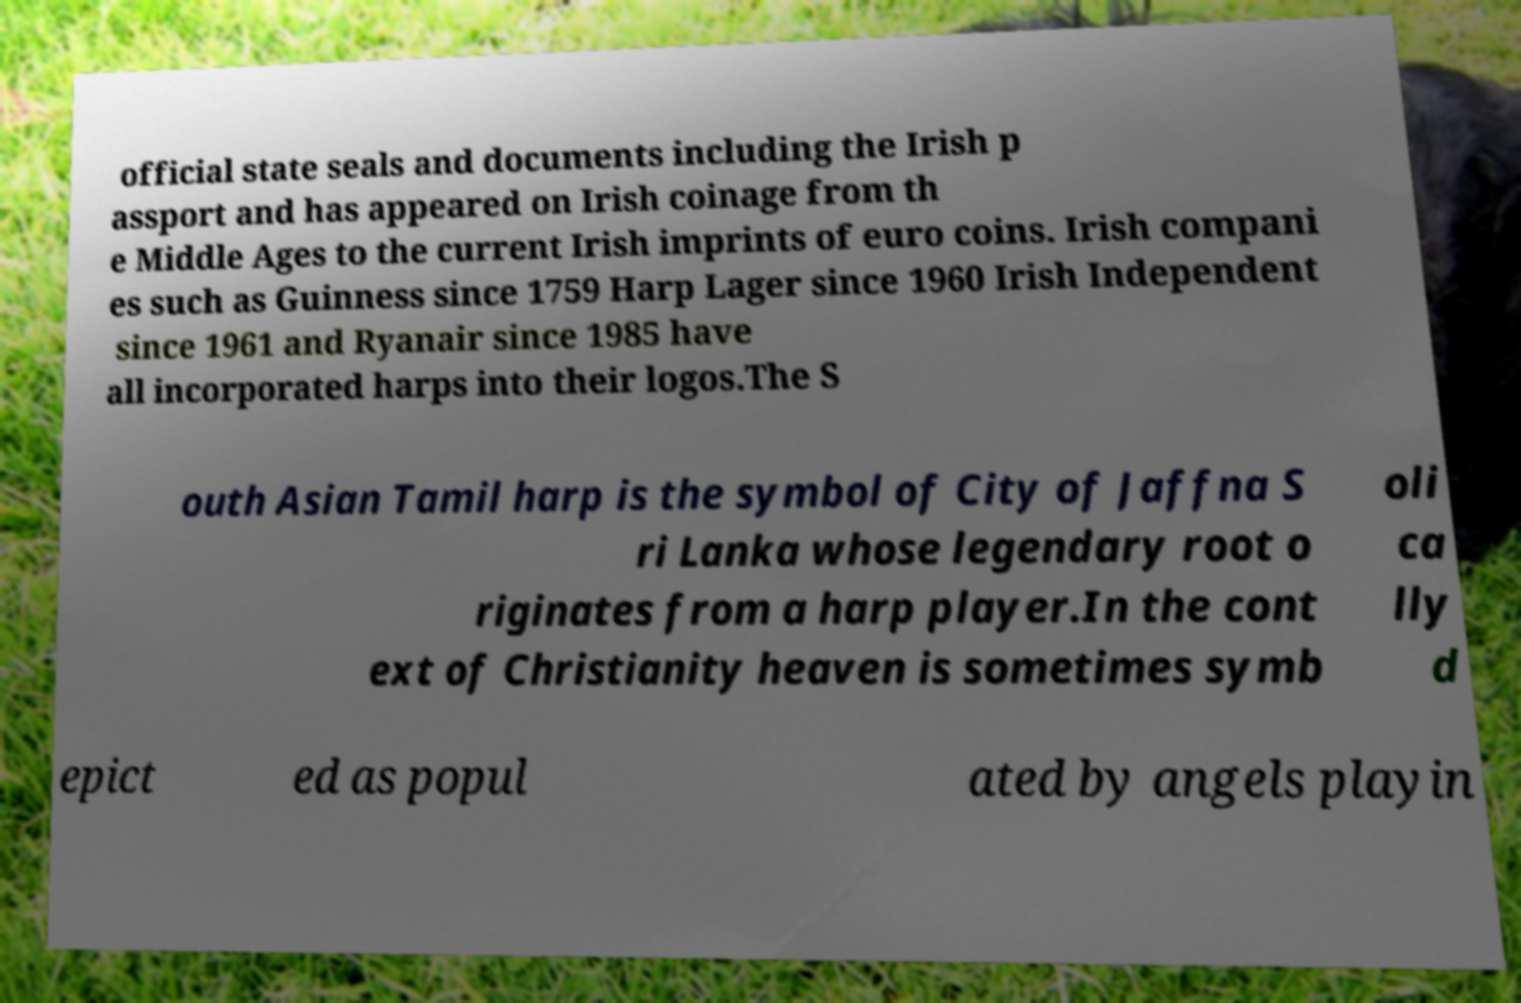For documentation purposes, I need the text within this image transcribed. Could you provide that? official state seals and documents including the Irish p assport and has appeared on Irish coinage from th e Middle Ages to the current Irish imprints of euro coins. Irish compani es such as Guinness since 1759 Harp Lager since 1960 Irish Independent since 1961 and Ryanair since 1985 have all incorporated harps into their logos.The S outh Asian Tamil harp is the symbol of City of Jaffna S ri Lanka whose legendary root o riginates from a harp player.In the cont ext of Christianity heaven is sometimes symb oli ca lly d epict ed as popul ated by angels playin 